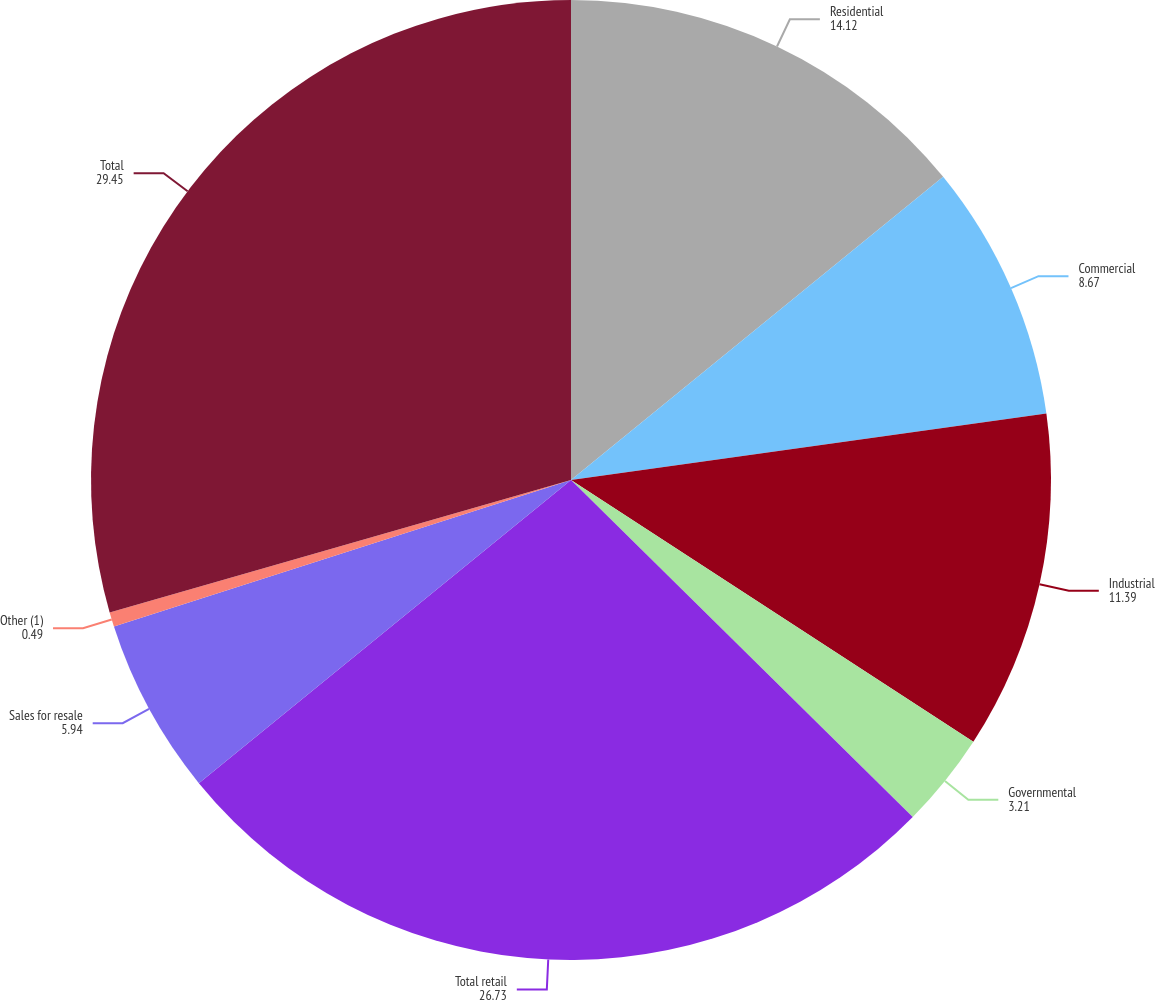<chart> <loc_0><loc_0><loc_500><loc_500><pie_chart><fcel>Residential<fcel>Commercial<fcel>Industrial<fcel>Governmental<fcel>Total retail<fcel>Sales for resale<fcel>Other (1)<fcel>Total<nl><fcel>14.12%<fcel>8.67%<fcel>11.39%<fcel>3.21%<fcel>26.73%<fcel>5.94%<fcel>0.49%<fcel>29.45%<nl></chart> 